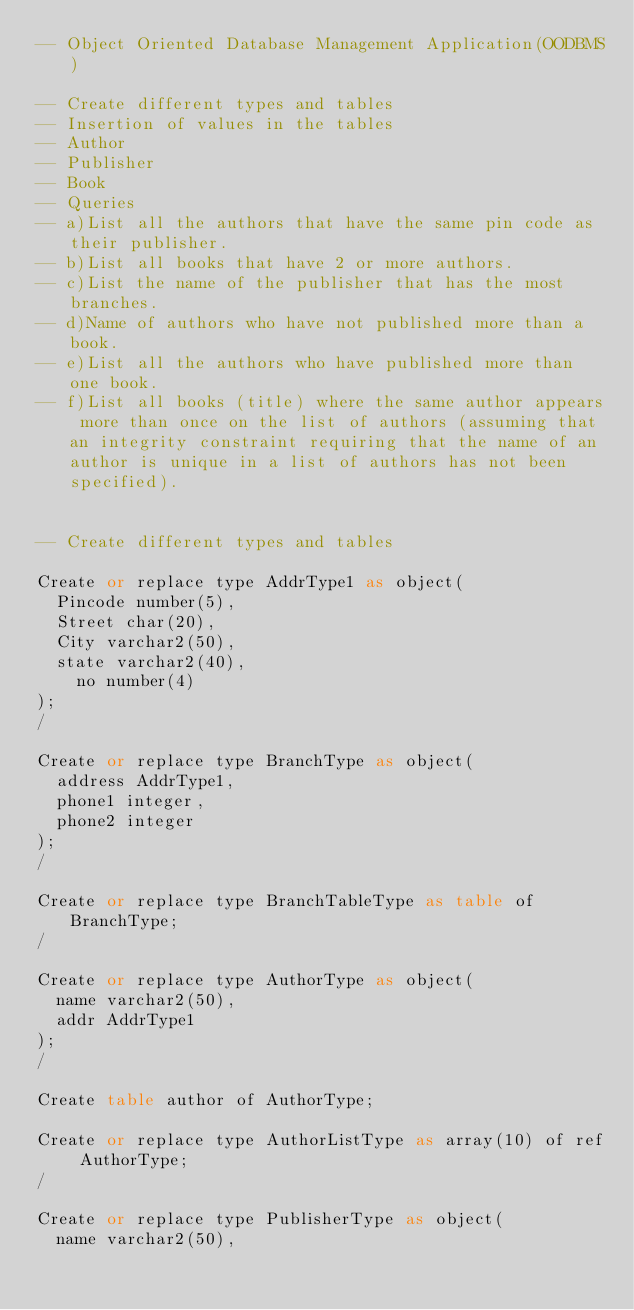<code> <loc_0><loc_0><loc_500><loc_500><_SQL_>-- Object Oriented Database Management Application(OODBMS)

-- Create different types and tables
-- Insertion of values in the tables
-- Author
-- Publisher
-- Book
-- Queries
-- a)List all the authors that have the same pin code as their publisher.
-- b)List all books that have 2 or more authors.
-- c)List the name of the publisher that has the most branches.
-- d)Name of authors who have not published more than a book.
-- e)List all the authors who have published more than one book.
-- f)List all books (title) where the same author appears more than once on the list of authors (assuming that an integrity constraint requiring that the name of an author is unique in a list of authors has not been specified).


-- Create different types and tables

Create or replace type AddrType1 as object( 
	Pincode number(5),										        
	Street char(20),											        
	City varchar2(50),										         
	state varchar2(40), 										       
  	no number(4)
);
/

Create or replace type BranchType as object(
	address AddrType1,											
	phone1 integer,
	phone2 integer
);
/

Create or replace type BranchTableType as table of BranchType;
/

Create or replace type AuthorType as object(
	name varchar2(50),
	addr AddrType1
);
/

Create table author of AuthorType;

Create or replace type AuthorListType as array(10) of ref AuthorType;
/

Create or replace type PublisherType as object(
	name varchar2(50),</code> 